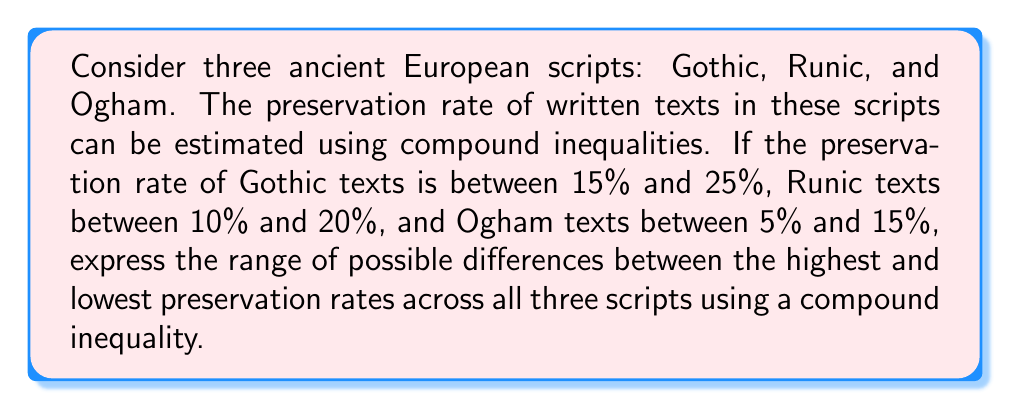Can you answer this question? To solve this problem, we need to follow these steps:

1. Identify the ranges for each script:
   Gothic: $15\% \leq x \leq 25\%$
   Runic: $10\% \leq y \leq 20\%$
   Ogham: $5\% \leq z \leq 15\%$

2. Find the maximum possible difference:
   The maximum difference occurs when we take the highest value for Gothic (25%) and the lowest value for Ogham (5%).
   $\text{Max difference} = 25\% - 5\% = 20\%$

3. Find the minimum possible difference:
   The minimum difference occurs when we take the lowest value for Gothic (15%) and the highest value for Runic (20%) or Ogham (15%).
   $\text{Min difference} = 20\% - 15\% = 5\%$ or $15\% - 15\% = 0\%$
   We choose the larger of these two, which is 5%.

4. Express the range as a compound inequality:
   Let $d$ be the difference between the highest and lowest preservation rates.
   $5\% \leq d \leq 20\%$

Therefore, the range of possible differences between the highest and lowest preservation rates across all three scripts can be expressed as:

$$5\% \leq d \leq 20\%$$
Answer: $5\% \leq d \leq 20\%$ 